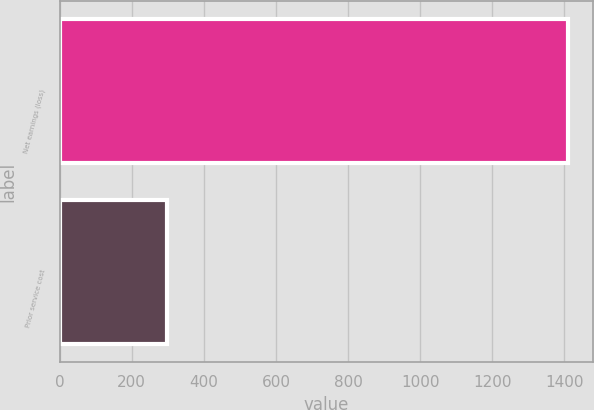Convert chart. <chart><loc_0><loc_0><loc_500><loc_500><bar_chart><fcel>Net earnings (loss)<fcel>Prior service cost<nl><fcel>1410<fcel>297<nl></chart> 